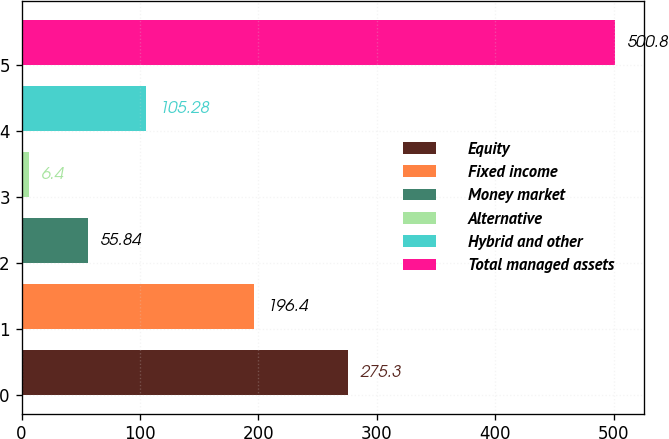Convert chart to OTSL. <chart><loc_0><loc_0><loc_500><loc_500><bar_chart><fcel>Equity<fcel>Fixed income<fcel>Money market<fcel>Alternative<fcel>Hybrid and other<fcel>Total managed assets<nl><fcel>275.3<fcel>196.4<fcel>55.84<fcel>6.4<fcel>105.28<fcel>500.8<nl></chart> 